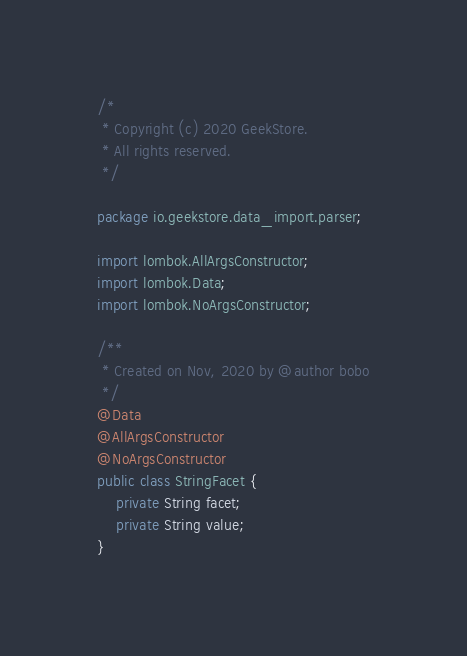<code> <loc_0><loc_0><loc_500><loc_500><_Java_>/*
 * Copyright (c) 2020 GeekStore.
 * All rights reserved.
 */

package io.geekstore.data_import.parser;

import lombok.AllArgsConstructor;
import lombok.Data;
import lombok.NoArgsConstructor;

/**
 * Created on Nov, 2020 by @author bobo
 */
@Data
@AllArgsConstructor
@NoArgsConstructor
public class StringFacet {
    private String facet;
    private String value;
}
</code> 